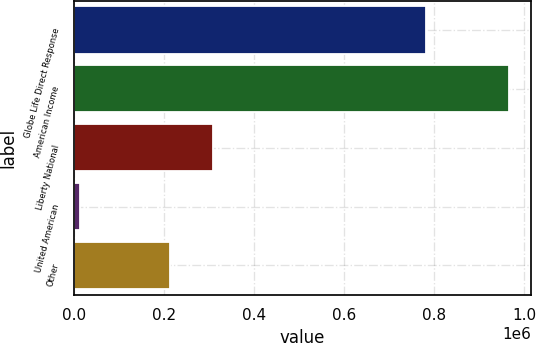<chart> <loc_0><loc_0><loc_500><loc_500><bar_chart><fcel>Globe Life Direct Response<fcel>American Income<fcel>Liberty National<fcel>United American<fcel>Other<nl><fcel>782222<fcel>966990<fcel>307597<fcel>13292<fcel>212227<nl></chart> 